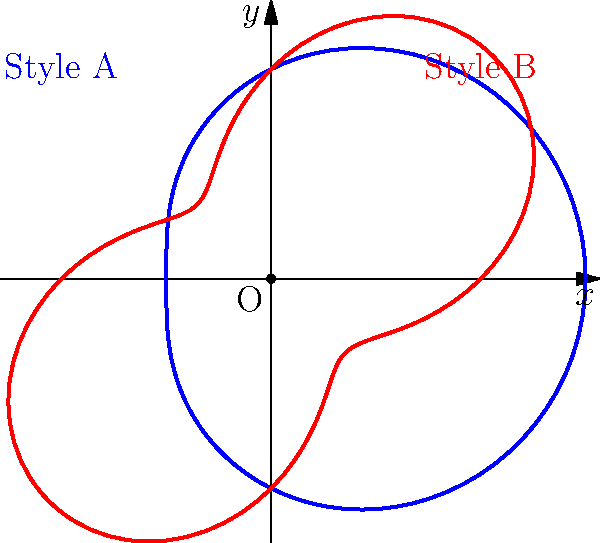In a creative hairstyling competition, two popular styles are represented by polar curves. Style A is given by $r = 2 + \cos\theta$ and Style B by $r = 2 + \sin(2\theta)$. Which style has a greater volume (represented by the area enclosed by its curve), and by what percentage is it larger? To solve this problem, we need to calculate the areas enclosed by both curves and compare them:

1. For Style A: $r = 2 + \cos\theta$
   Area = $\frac{1}{2}\int_0^{2\pi} r^2 d\theta = \frac{1}{2}\int_0^{2\pi} (2 + \cos\theta)^2 d\theta$
   $= \frac{1}{2}\int_0^{2\pi} (4 + 4\cos\theta + \cos^2\theta) d\theta$
   $= \frac{1}{2}[4\theta + 4\sin\theta + \frac{1}{2}\theta + \frac{1}{4}\sin(2\theta)]_0^{2\pi}$
   $= \frac{1}{2}[8\pi + 0 + \pi + 0] = \frac{9\pi}{2} \approx 14.14$

2. For Style B: $r = 2 + \sin(2\theta)$
   Area = $\frac{1}{2}\int_0^{2\pi} r^2 d\theta = \frac{1}{2}\int_0^{2\pi} (2 + \sin(2\theta))^2 d\theta$
   $= \frac{1}{2}\int_0^{2\pi} (4 + 4\sin(2\theta) + \sin^2(2\theta)) d\theta$
   $= \frac{1}{2}[4\theta + 2\cos(2\theta) + \frac{1}{2}\theta - \frac{1}{8}\sin(4\theta)]_0^{2\pi}$
   $= \frac{1}{2}[8\pi + 0 + \pi + 0] = \frac{9\pi}{2} \approx 14.14$

3. Both styles have the same area, so neither has a greater volume.

4. The percentage difference is 0% since they are equal.
Answer: Neither; 0% 